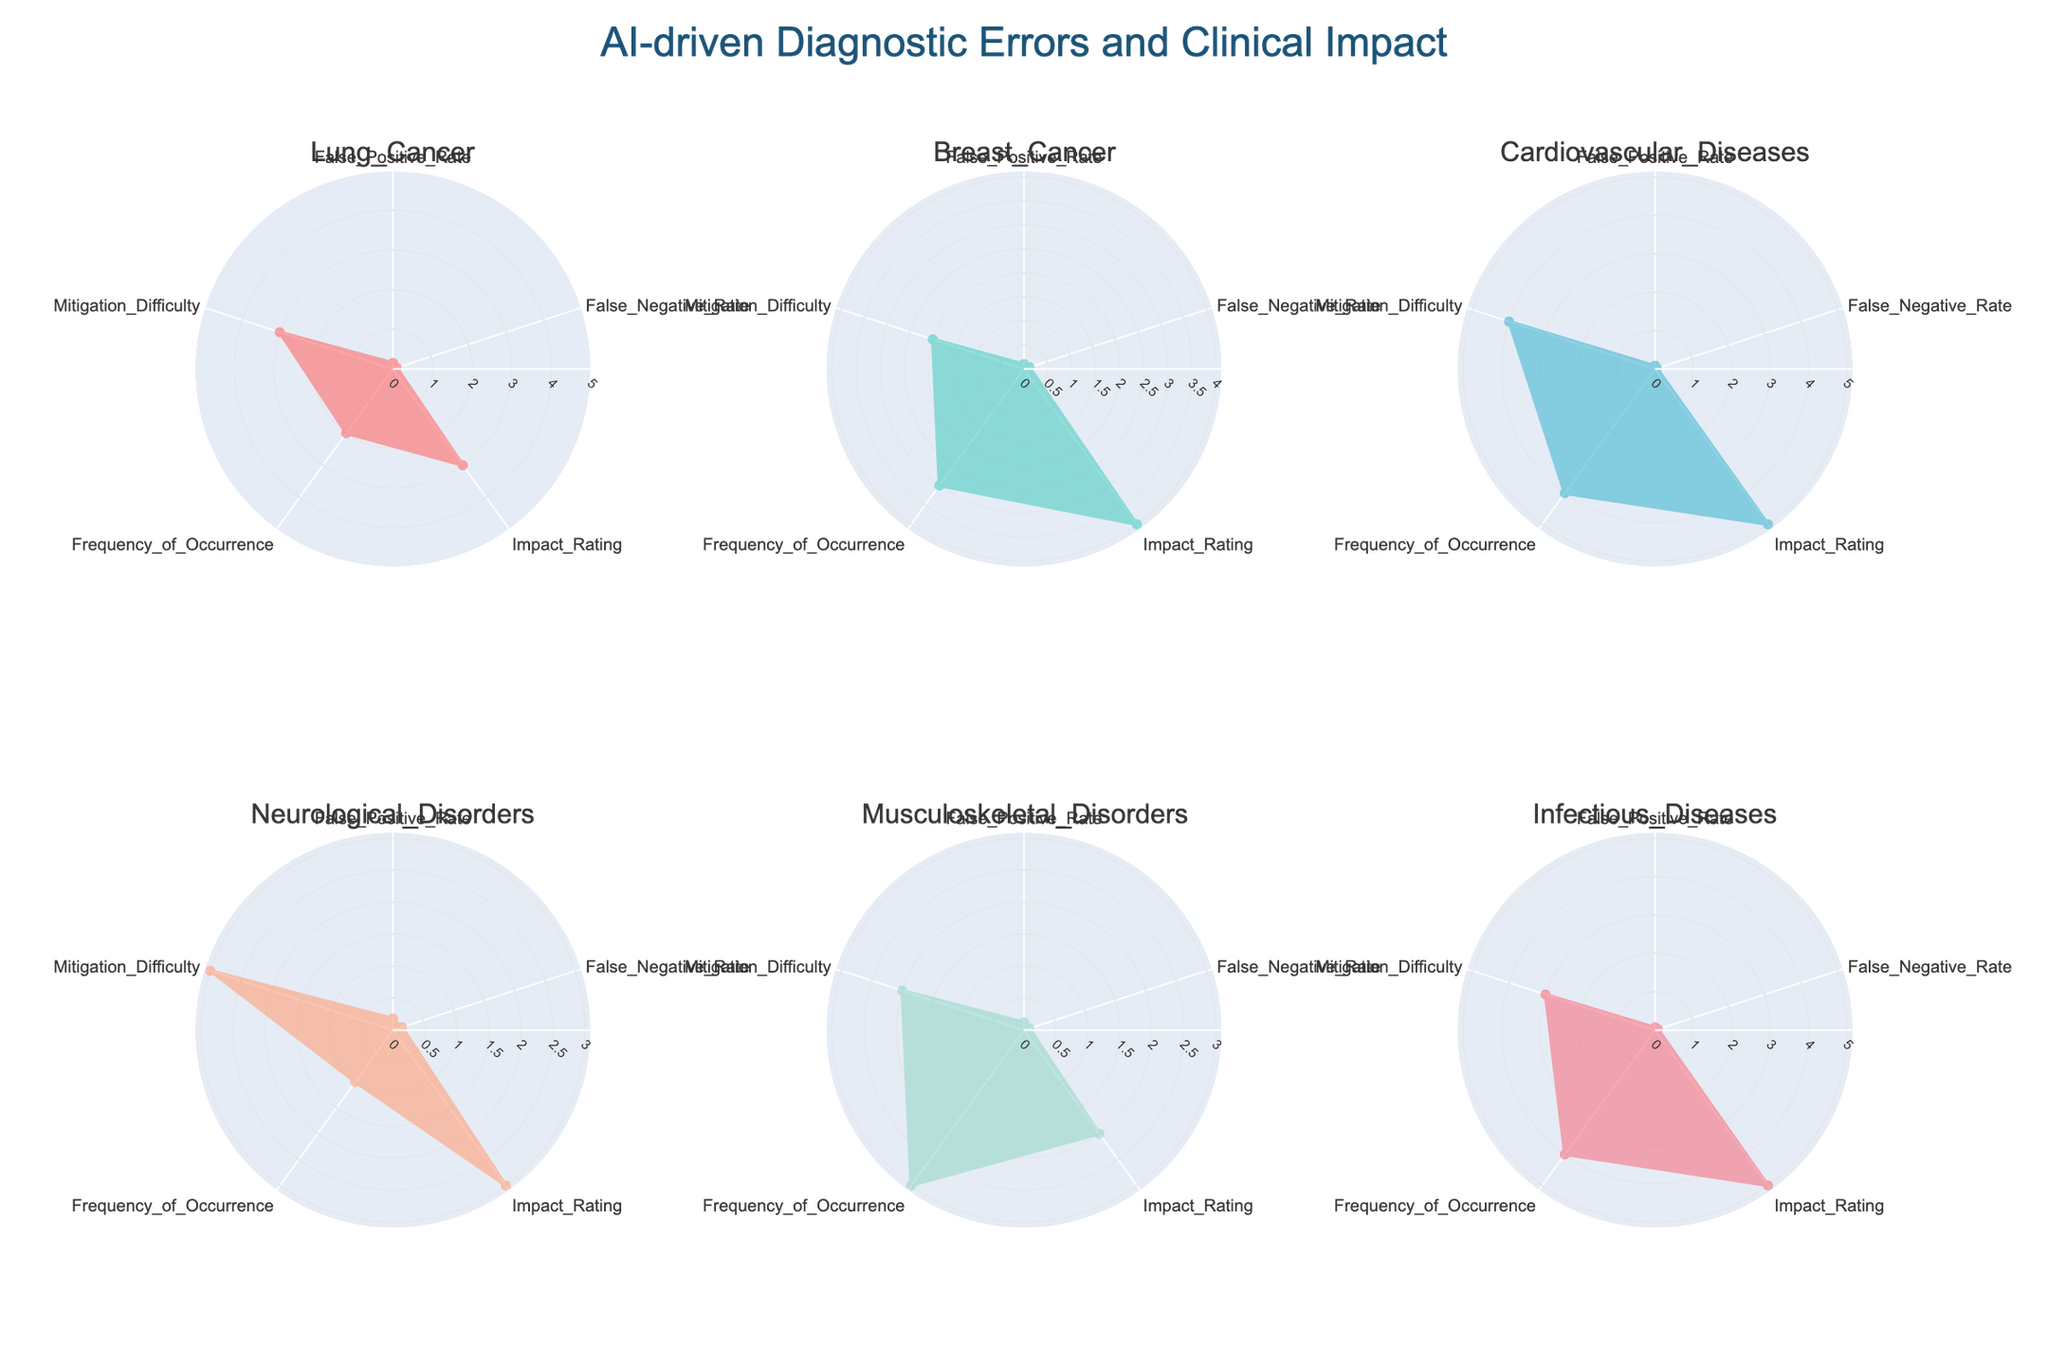What is the title of the figure? The title of the figure is usually displayed at the top. Observing the top center of the figure, it reads "AI-driven Diagnostic Errors and Clinical Impact".
Answer: AI-driven Diagnostic Errors and Clinical Impact Which disease category has the highest false negative rate? By analyzing the false negative rates in the radar charts, Neurological Disorders has the highest false negative rate at 0.15, as indicated by its radial extent in the False_Negative_Rate metric.
Answer: Neurological Disorders What is the median impact rating across all categories? To find the median impact rating, list all impact ratings: 3 (Lung Cancer), 4 (Breast Cancer), 5 (Cardiovascular Diseases), 3 (Neurological Disorders), 2 (Musculoskeletal_Disorders), 5 (Infectious Diseases). Arrange in order: 2, 3, 3, 4, 5, 5. The median is the average of the third and fourth values: (3 + 4)/2 = 3.5.
Answer: 3.5 Which disease categories have an equal false positive and false negative rate? According to the radar charts, Musculoskeletal Disorders has approximately equal false positive and false negative rates at around 0.09 and 0.08, respectively.
Answer: Musculoskeletal Disorders Between Lung Cancer and Breast Cancer, which has higher mitigation difficulty? Comparing the radar charts for Lung Cancer and Breast Cancer, Lung Cancer has a mitigation difficulty of 3, while Breast Cancer has a mitigation difficulty of 2. Therefore, Lung Cancer has a higher mitigation difficulty.
Answer: Lung Cancer What is the sum of the frequency of occurrence for Cardiovascular Diseases and Infectious Diseases? From the radar charts, the frequency of occurrence for Cardiovascular Diseases is 4, and for Infectious Diseases is also 4. Summing these gives 4 + 4 = 8.
Answer: 8 Which category has the lowest false positive rate and what is its value? Looking at all categories, Infectious Diseases has the lowest false positive rate at 0.07, as indicated in the radar chart.
Answer: Infectious Diseases, 0.07 Which category has the highest impact rating and what is its value? By analyzing the radar charts, Cardiovascular Diseases and Infectious Diseases both have the highest impact rating of 5.
Answer: Cardiovascular Diseases and Infectious Diseases, 5 